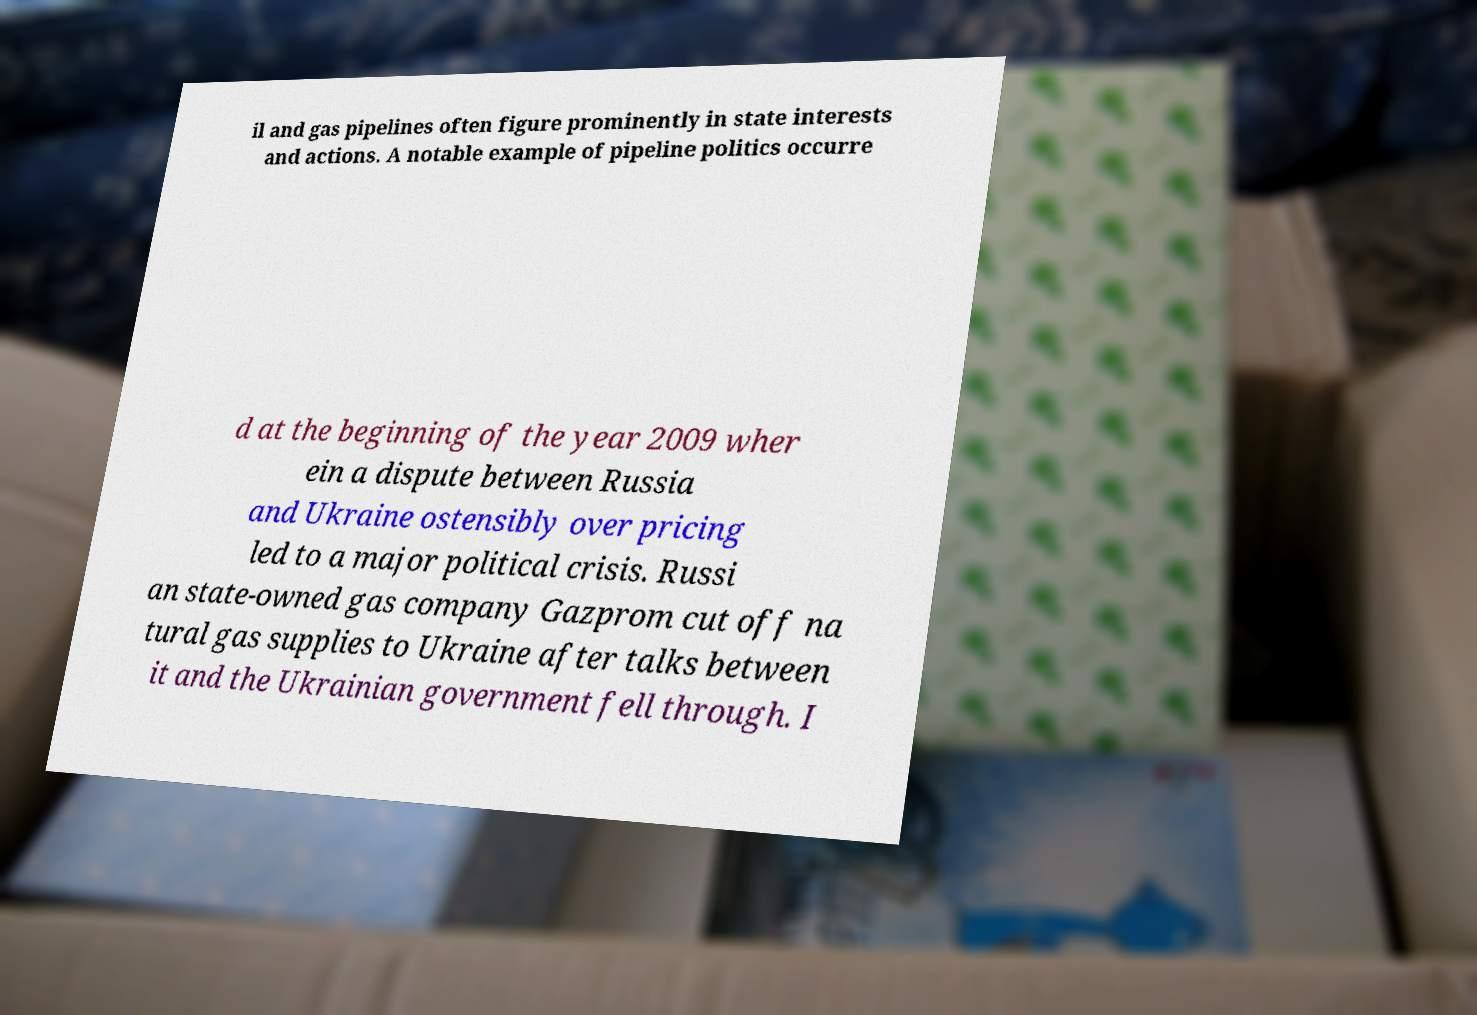Please identify and transcribe the text found in this image. il and gas pipelines often figure prominently in state interests and actions. A notable example of pipeline politics occurre d at the beginning of the year 2009 wher ein a dispute between Russia and Ukraine ostensibly over pricing led to a major political crisis. Russi an state-owned gas company Gazprom cut off na tural gas supplies to Ukraine after talks between it and the Ukrainian government fell through. I 